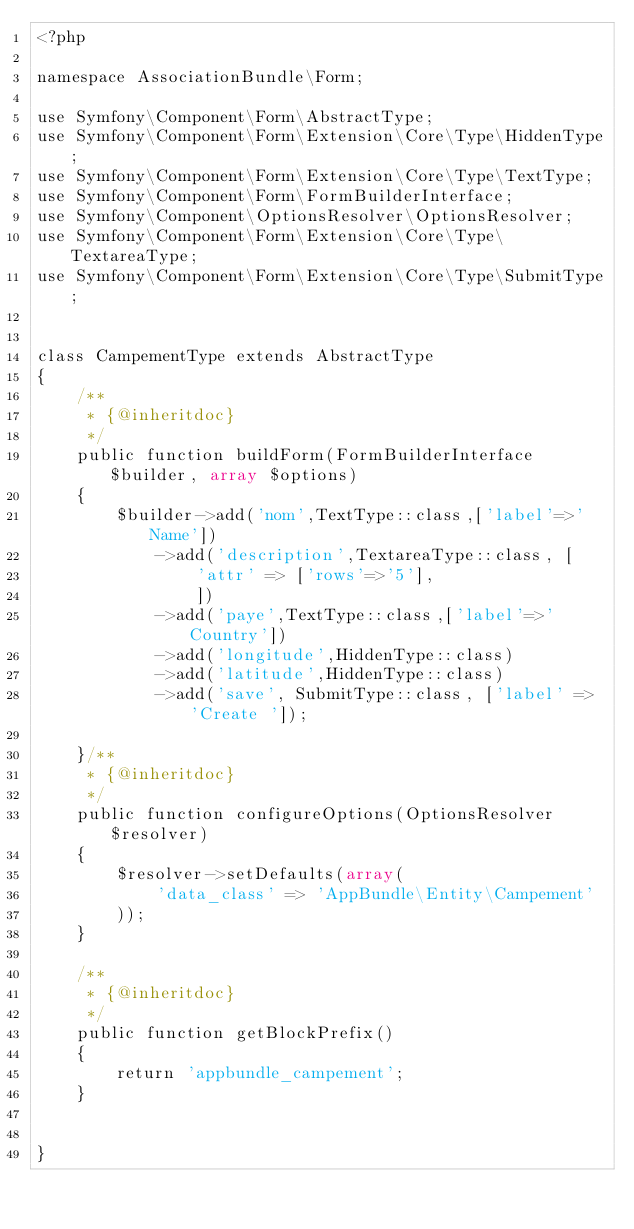<code> <loc_0><loc_0><loc_500><loc_500><_PHP_><?php

namespace AssociationBundle\Form;

use Symfony\Component\Form\AbstractType;
use Symfony\Component\Form\Extension\Core\Type\HiddenType;
use Symfony\Component\Form\Extension\Core\Type\TextType;
use Symfony\Component\Form\FormBuilderInterface;
use Symfony\Component\OptionsResolver\OptionsResolver;
use Symfony\Component\Form\Extension\Core\Type\TextareaType;
use Symfony\Component\Form\Extension\Core\Type\SubmitType;


class CampementType extends AbstractType
{
    /**
     * {@inheritdoc}
     */
    public function buildForm(FormBuilderInterface $builder, array $options)
    {
        $builder->add('nom',TextType::class,['label'=>'Name'])
            ->add('description',TextareaType::class, [
                'attr' => ['rows'=>'5'],
                ])
            ->add('paye',TextType::class,['label'=>'Country'])
            ->add('longitude',HiddenType::class)
            ->add('latitude',HiddenType::class)
            ->add('save', SubmitType::class, ['label' => 'Create ']);

    }/**
     * {@inheritdoc}
     */
    public function configureOptions(OptionsResolver $resolver)
    {
        $resolver->setDefaults(array(
            'data_class' => 'AppBundle\Entity\Campement'
        ));
    }

    /**
     * {@inheritdoc}
     */
    public function getBlockPrefix()
    {
        return 'appbundle_campement';
    }


}
</code> 